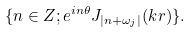Convert formula to latex. <formula><loc_0><loc_0><loc_500><loc_500>\{ n \in { Z } ; e ^ { i n \theta } J _ { | n + \omega _ { j } | } ( k r ) \} .</formula> 